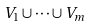<formula> <loc_0><loc_0><loc_500><loc_500>V _ { 1 } \cup \cdots \cup V _ { m }</formula> 